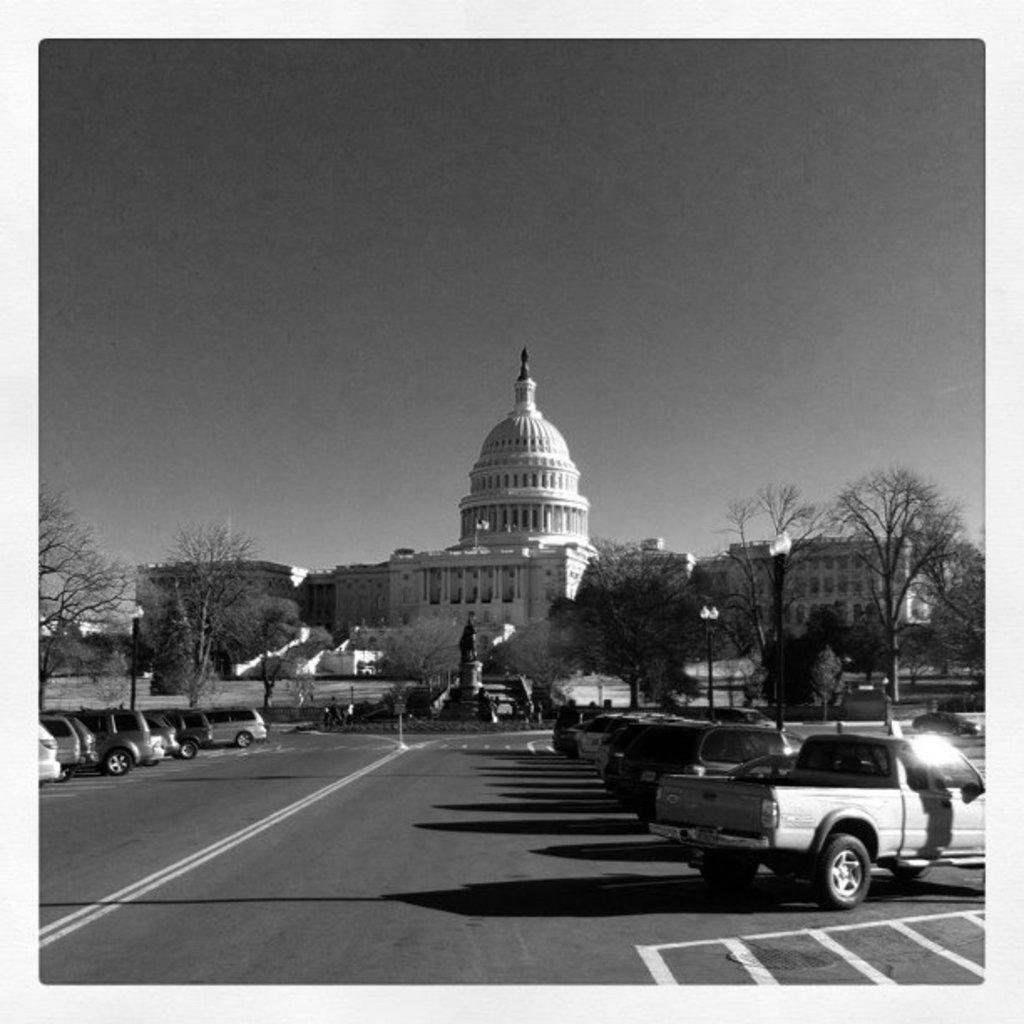Can you describe this image briefly? In the foreground of this black and white image, there is a road, few vehicles and trees. In the background, there is a building and a sculpture like structure. At the top, there is the sky. 